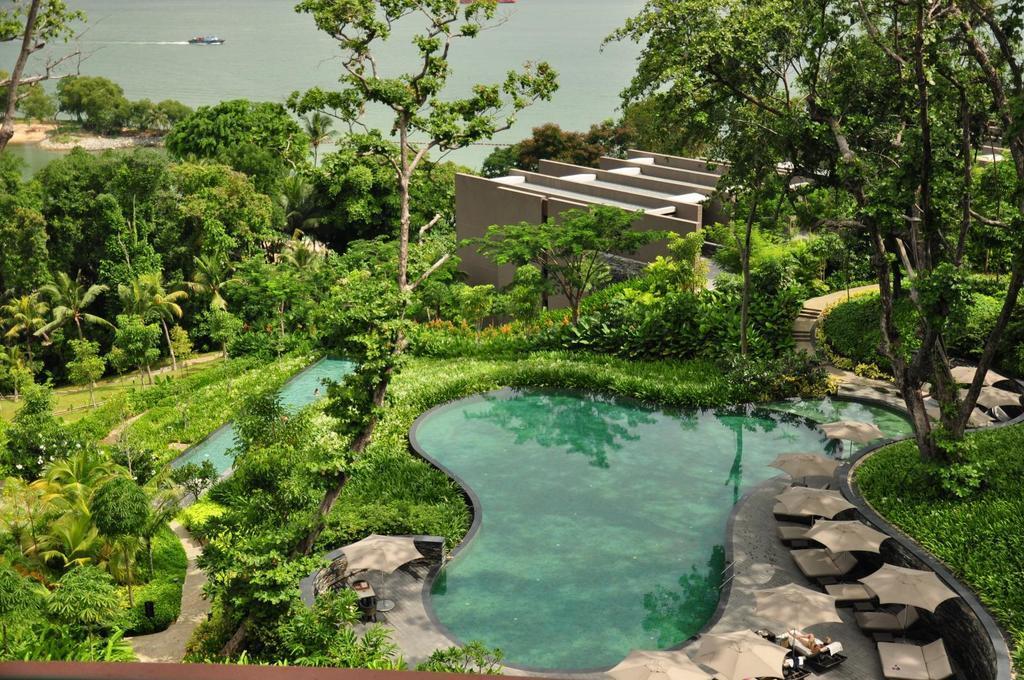Can you describe this image briefly? In this image I can see the ground, few plants, few trees which are green in color, few umbrellas, for beach beds, few swimming pools and a building. In the background I can see the water and a boat on the surface of the water. 